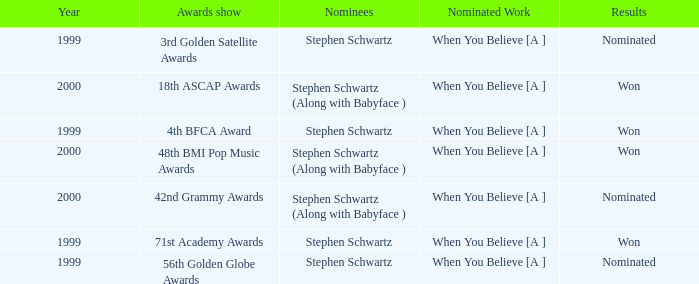What was the result in 2000? Won, Won, Nominated. 